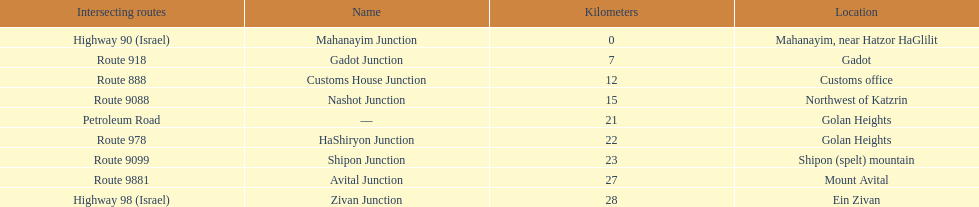What is the total kilometers that separates the mahanayim junction and the shipon junction? 23. 